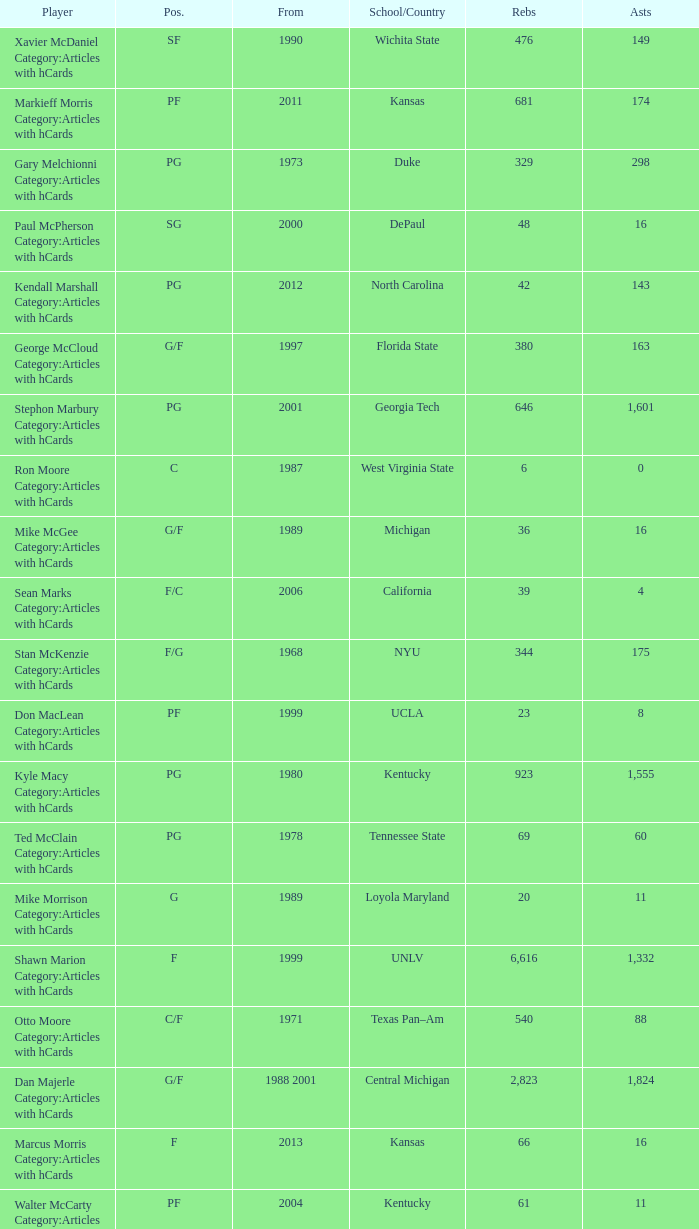What position does the player from arkansas play? C. 